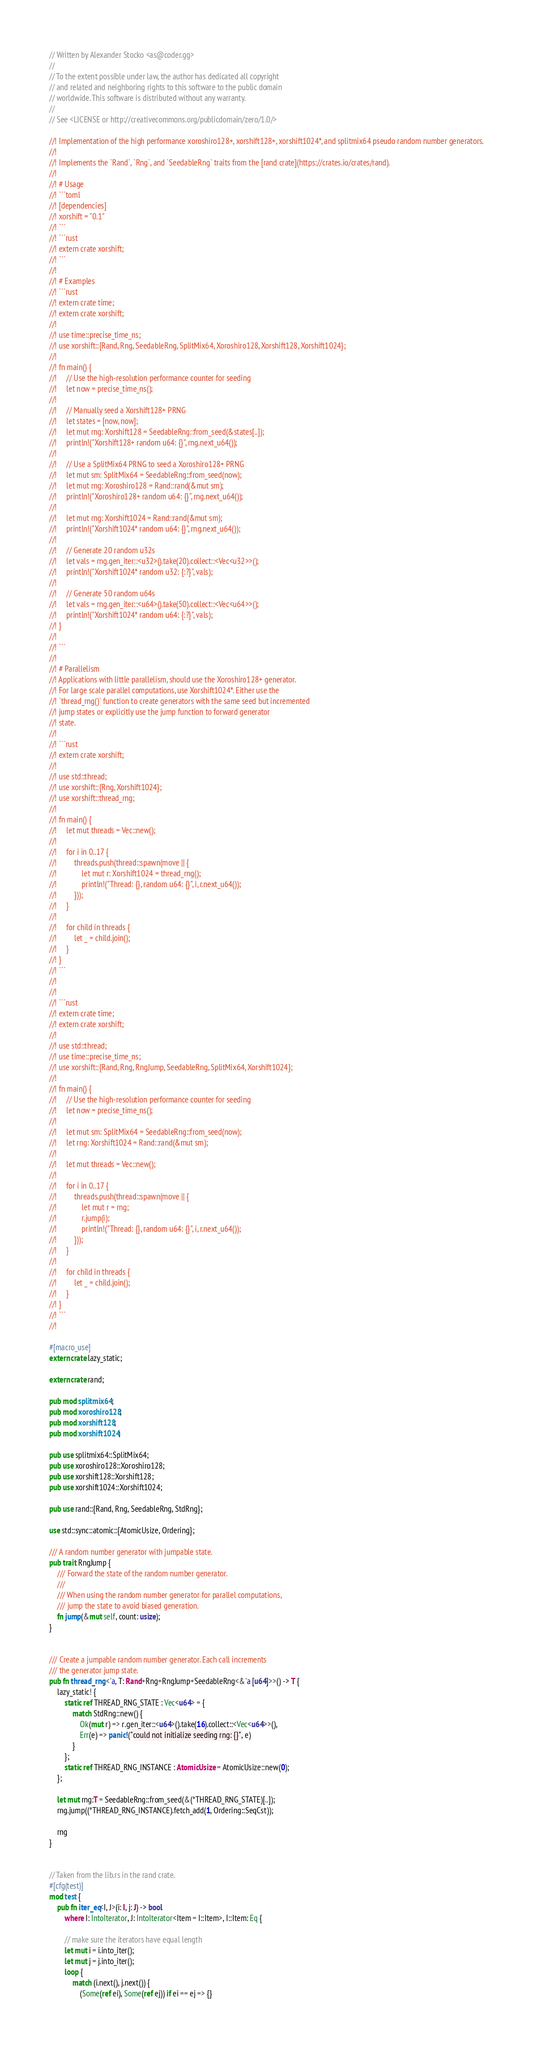<code> <loc_0><loc_0><loc_500><loc_500><_Rust_>// Written by Alexander Stocko <as@coder.gg>
//
// To the extent possible under law, the author has dedicated all copyright
// and related and neighboring rights to this software to the public domain
// worldwide. This software is distributed without any warranty.
//
// See <LICENSE or http://creativecommons.org/publicdomain/zero/1.0/>

//! Implementation of the high performance xoroshiro128+, xorshift128+, xorshift1024*, and splitmix64 pseudo random number generators.
//!
//! Implements the `Rand`, `Rng`, and `SeedableRng` traits from the [rand crate](https://crates.io/crates/rand).
//!
//! # Usage
//! ```toml
//! [dependencies]
//! xorshift = "0.1"
//! ```
//! ```rust
//! extern crate xorshift;
//! ```
//!
//! # Examples
//! ```rust
//! extern crate time;
//! extern crate xorshift;
//!
//! use time::precise_time_ns;
//! use xorshift::{Rand, Rng, SeedableRng, SplitMix64, Xoroshiro128, Xorshift128, Xorshift1024};
//!
//! fn main() {
//!     // Use the high-resolution performance counter for seeding
//!     let now = precise_time_ns();
//!
//!     // Manually seed a Xorshift128+ PRNG
//!     let states = [now, now];
//!     let mut rng: Xorshift128 = SeedableRng::from_seed(&states[..]);
//!     println!("Xorshift128+ random u64: {}", rng.next_u64());
//!
//!     // Use a SplitMix64 PRNG to seed a Xoroshiro128+ PRNG
//!     let mut sm: SplitMix64 = SeedableRng::from_seed(now);
//!     let mut rng: Xoroshiro128 = Rand::rand(&mut sm);
//!     println!("Xoroshiro128+ random u64: {}", rng.next_u64());
//!
//!     let mut rng: Xorshift1024 = Rand::rand(&mut sm);
//!     println!("Xorshift1024* random u64: {}", rng.next_u64());
//!
//!     // Generate 20 random u32s
//!     let vals = rng.gen_iter::<u32>().take(20).collect::<Vec<u32>>();
//!     println!("Xorshift1024* random u32: {:?}", vals);
//!
//!     // Generate 50 random u64s
//!     let vals = rng.gen_iter::<u64>().take(50).collect::<Vec<u64>>();
//!     println!("Xorshift1024* random u64: {:?}", vals);
//! }
//!
//! ```
//!
//! # Parallelism
//! Applications with little parallelism, should use the Xoroshiro128+ generator.
//! For large scale parallel computations, use Xorshift1024*. Either use the
//! `thread_rng()` function to create generators with the same seed but incremented
//! jump states or explicitly use the jump function to forward generator
//! state.
//!
//! ```rust
//! extern crate xorshift;
//!
//! use std::thread;
//! use xorshift::{Rng, Xorshift1024};
//! use xorshift::thread_rng;
//!
//! fn main() {
//!     let mut threads = Vec::new();
//!
//!     for i in 0..17 {
//!         threads.push(thread::spawn(move || {
//!             let mut r: Xorshift1024 = thread_rng();
//!             println!("Thread: {}, random u64: {}", i, r.next_u64());
//!         }));
//!     }
//!
//!     for child in threads {
//!         let _ = child.join();
//!     }
//! }
//! ```
//!
//!
//! ```rust
//! extern crate time;
//! extern crate xorshift;
//!
//! use std::thread;
//! use time::precise_time_ns;
//! use xorshift::{Rand, Rng, RngJump, SeedableRng, SplitMix64, Xorshift1024};
//!
//! fn main() {
//!     // Use the high-resolution performance counter for seeding
//!     let now = precise_time_ns();
//!
//!     let mut sm: SplitMix64 = SeedableRng::from_seed(now);
//!     let rng: Xorshift1024 = Rand::rand(&mut sm);
//!
//!     let mut threads = Vec::new();
//!
//!     for i in 0..17 {
//!         threads.push(thread::spawn(move || {
//!             let mut r = rng;
//!             r.jump(i);
//!             println!("Thread: {}, random u64: {}", i, r.next_u64());
//!         }));
//!     }
//!
//!     for child in threads {
//!         let _ = child.join();
//!     }
//! }
//! ```
//!

#[macro_use]
extern crate lazy_static;

extern crate rand;

pub mod splitmix64;
pub mod xoroshiro128;
pub mod xorshift128;
pub mod xorshift1024;

pub use splitmix64::SplitMix64;
pub use xoroshiro128::Xoroshiro128;
pub use xorshift128::Xorshift128;
pub use xorshift1024::Xorshift1024;

pub use rand::{Rand, Rng, SeedableRng, StdRng};

use std::sync::atomic::{AtomicUsize, Ordering};

/// A random number generator with jumpable state.
pub trait RngJump {
    /// Forward the state of the random number generator.
    ///
    /// When using the random number generator for parallel computations,
    /// jump the state to avoid biased generation.
    fn jump(&mut self, count: usize);
}


/// Create a jumpable random number generator. Each call increments
/// the generator jump state.
pub fn thread_rng <'a, T: Rand+Rng+RngJump+SeedableRng<&'a [u64]>>() -> T {
    lazy_static! {
        static ref THREAD_RNG_STATE : Vec<u64> = {
            match StdRng::new() {
                Ok(mut r) => r.gen_iter::<u64>().take(16).collect::<Vec<u64>>(),
                Err(e) => panic!("could not initialize seeding rng: {}", e)
            }
        };
        static ref THREAD_RNG_INSTANCE : AtomicUsize = AtomicUsize::new(0);
    };

    let mut rng:T = SeedableRng::from_seed(&(*THREAD_RNG_STATE)[..]);
    rng.jump((*THREAD_RNG_INSTANCE).fetch_add(1, Ordering::SeqCst));

    rng
}


// Taken from the lib.rs in the rand crate.
#[cfg(test)]
mod test {
    pub fn iter_eq<I, J>(i: I, j: J) -> bool
        where I: IntoIterator, J: IntoIterator<Item = I::Item>, I::Item: Eq {

        // make sure the iterators have equal length
        let mut i = i.into_iter();
        let mut j = j.into_iter();
        loop {
            match (i.next(), j.next()) {
                (Some(ref ei), Some(ref ej)) if ei == ej => {}</code> 